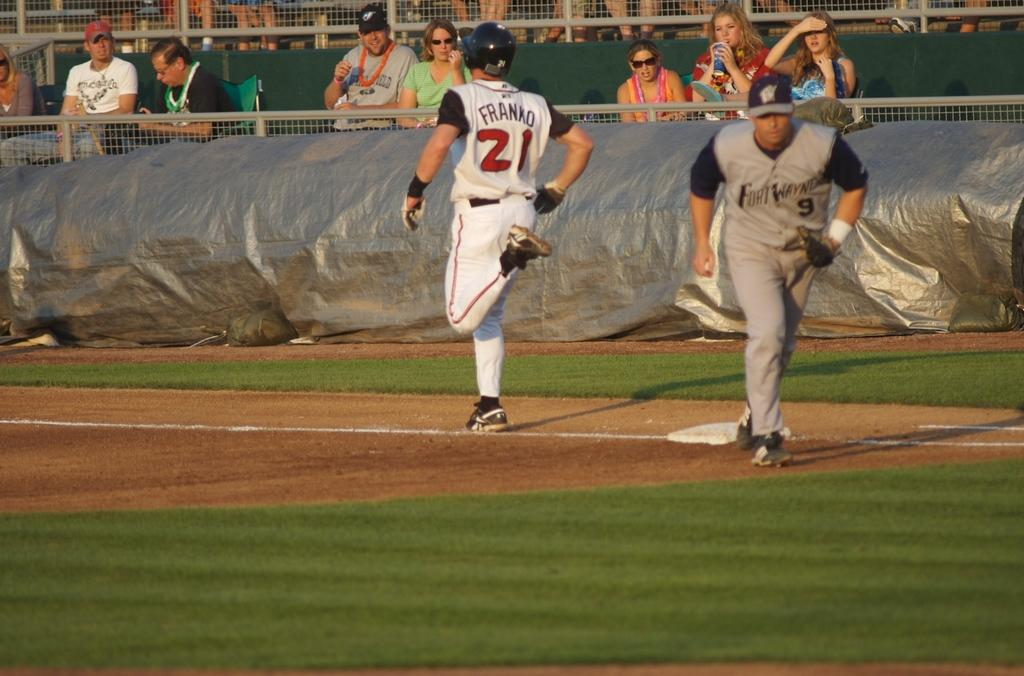Provide a one-sentence caption for the provided image. Baseball player Franko is running for a base. 